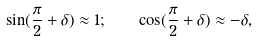<formula> <loc_0><loc_0><loc_500><loc_500>\sin ( \frac { \pi } { 2 } + \delta ) \approx 1 ; \quad \cos ( \frac { \pi } { 2 } + \delta ) \approx - \delta ,</formula> 